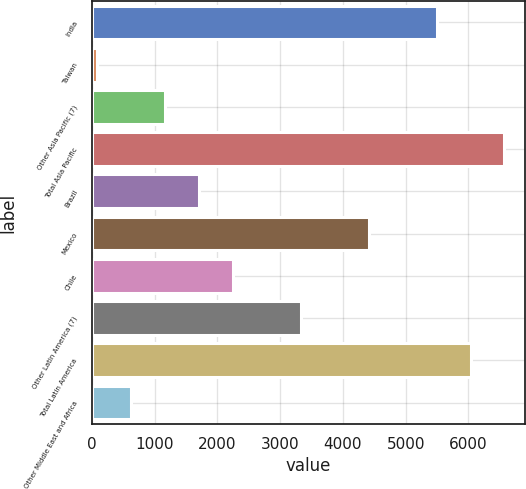Convert chart to OTSL. <chart><loc_0><loc_0><loc_500><loc_500><bar_chart><fcel>India<fcel>Taiwan<fcel>Other Asia Pacific (7)<fcel>Total Asia Pacific<fcel>Brazil<fcel>Mexico<fcel>Chile<fcel>Other Latin America (7)<fcel>Total Latin America<fcel>Other Middle East and Africa<nl><fcel>5492<fcel>86<fcel>1167.2<fcel>6573.2<fcel>1707.8<fcel>4410.8<fcel>2248.4<fcel>3329.6<fcel>6032.6<fcel>626.6<nl></chart> 